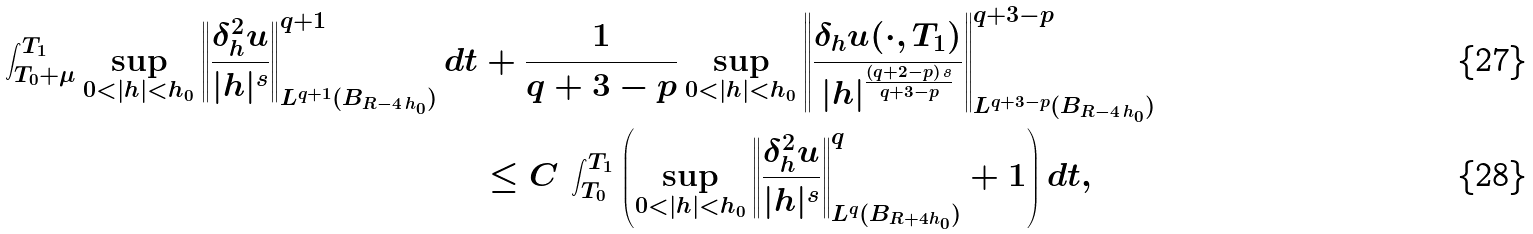Convert formula to latex. <formula><loc_0><loc_0><loc_500><loc_500>\int _ { T _ { 0 } + \mu } ^ { T _ { 1 } } \sup _ { 0 < | h | < h _ { 0 } } \left \| \frac { \delta ^ { 2 } _ { h } u } { | h | ^ { s } } \right \| _ { L ^ { q + 1 } ( B _ { R - 4 \, h _ { 0 } } ) } ^ { q + 1 } d t & + \frac { 1 } { q + 3 - p } \sup _ { 0 < | h | < h _ { 0 } } \left \| \frac { \delta _ { h } u ( \cdot , T _ { 1 } ) } { | h | ^ { \frac { ( q + 2 - p ) \, s } { q + 3 - p } } } \right \| _ { L ^ { q + 3 - p } ( B _ { R - 4 \, h _ { 0 } } ) } ^ { q + 3 - p } \\ & \leq C \, \int _ { T _ { 0 } } ^ { T _ { 1 } } \left ( \sup _ { 0 < | h | < h _ { 0 } } \left \| \frac { \delta ^ { 2 } _ { h } u } { | h | ^ { s } } \right \| _ { L ^ { q } ( B _ { R + 4 h _ { 0 } } ) } ^ { q } + 1 \right ) d t ,</formula> 